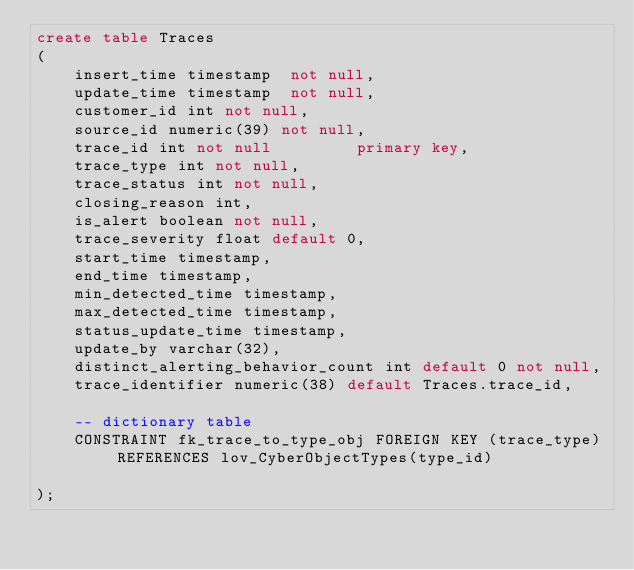Convert code to text. <code><loc_0><loc_0><loc_500><loc_500><_SQL_>create table Traces
(
    insert_time timestamp  not null,
    update_time timestamp  not null,
    customer_id int not null,
    source_id numeric(39) not null,
    trace_id int not null         primary key,
    trace_type int not null,
    trace_status int not null,
    closing_reason int,
    is_alert boolean not null,
    trace_severity float default 0,
    start_time timestamp,
    end_time timestamp,
    min_detected_time timestamp,
    max_detected_time timestamp,
    status_update_time timestamp,
    update_by varchar(32),
    distinct_alerting_behavior_count int default 0 not null,
    trace_identifier numeric(38) default Traces.trace_id,

    -- dictionary table
    CONSTRAINT fk_trace_to_type_obj FOREIGN KEY (trace_type) REFERENCES lov_CyberObjectTypes(type_id)

);

</code> 